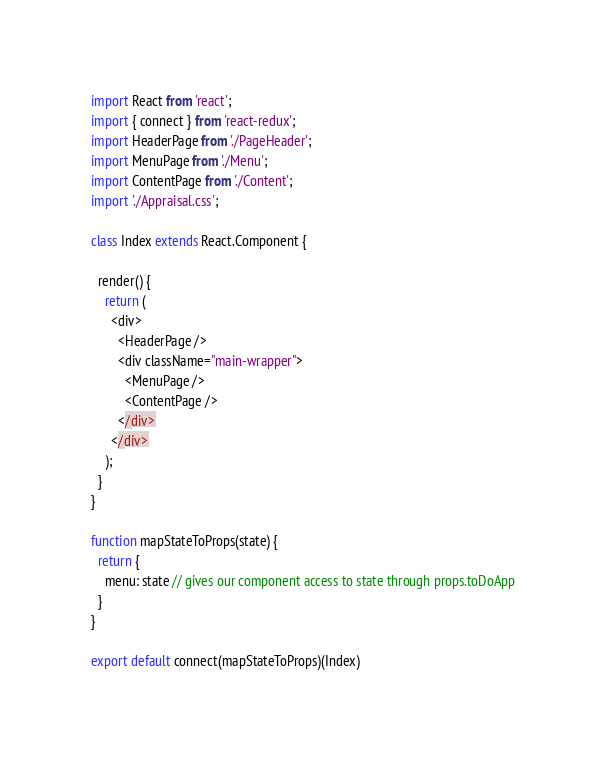Convert code to text. <code><loc_0><loc_0><loc_500><loc_500><_JavaScript_>import React from 'react';
import { connect } from 'react-redux';
import HeaderPage from './PageHeader';
import MenuPage from './Menu';
import ContentPage from './Content';
import './Appraisal.css';

class Index extends React.Component {

  render() {
    return (
      <div>
        <HeaderPage />
        <div className="main-wrapper">
          <MenuPage />
          <ContentPage />
        </div>
      </div>
    );
  }
}

function mapStateToProps(state) {
  return {
    menu: state // gives our component access to state through props.toDoApp
  }
}

export default connect(mapStateToProps)(Index)</code> 